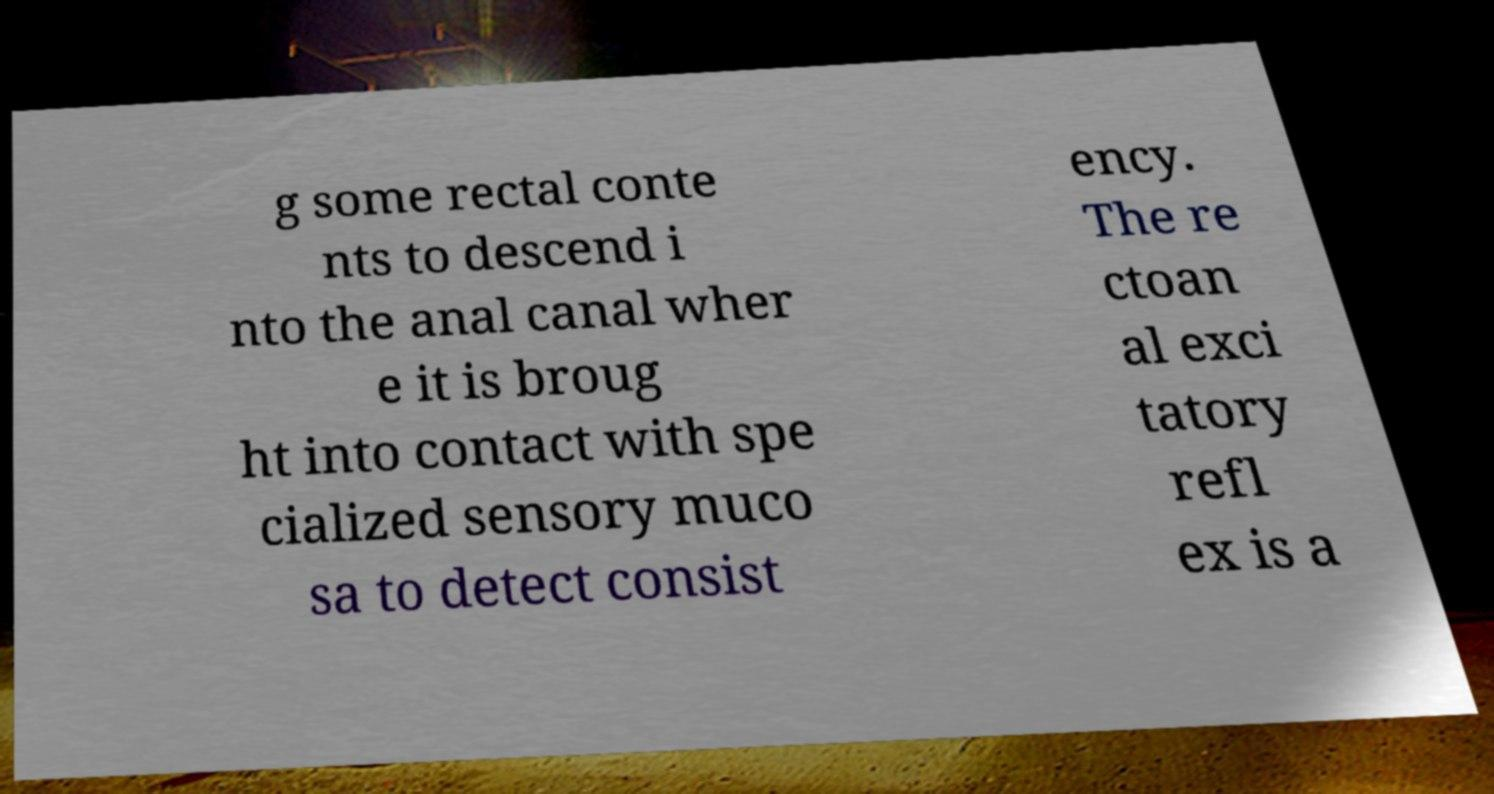I need the written content from this picture converted into text. Can you do that? g some rectal conte nts to descend i nto the anal canal wher e it is broug ht into contact with spe cialized sensory muco sa to detect consist ency. The re ctoan al exci tatory refl ex is a 